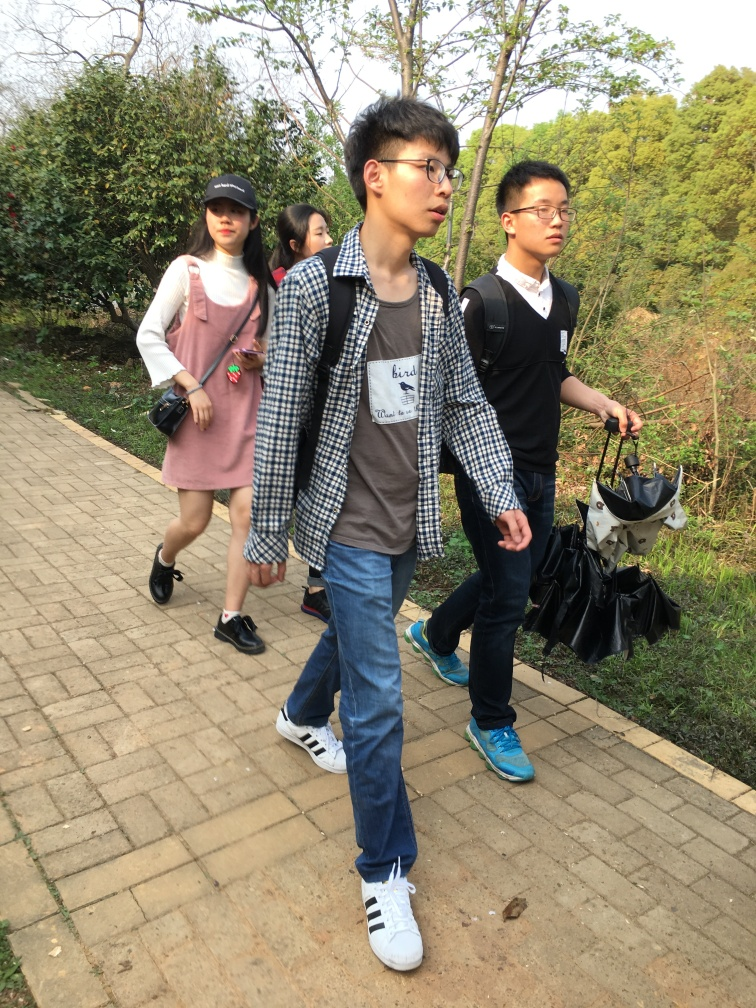Is the brightness level appropriate in the photo?
A. No
B. Yes
Answer with the option's letter from the given choices directly.
 B. 